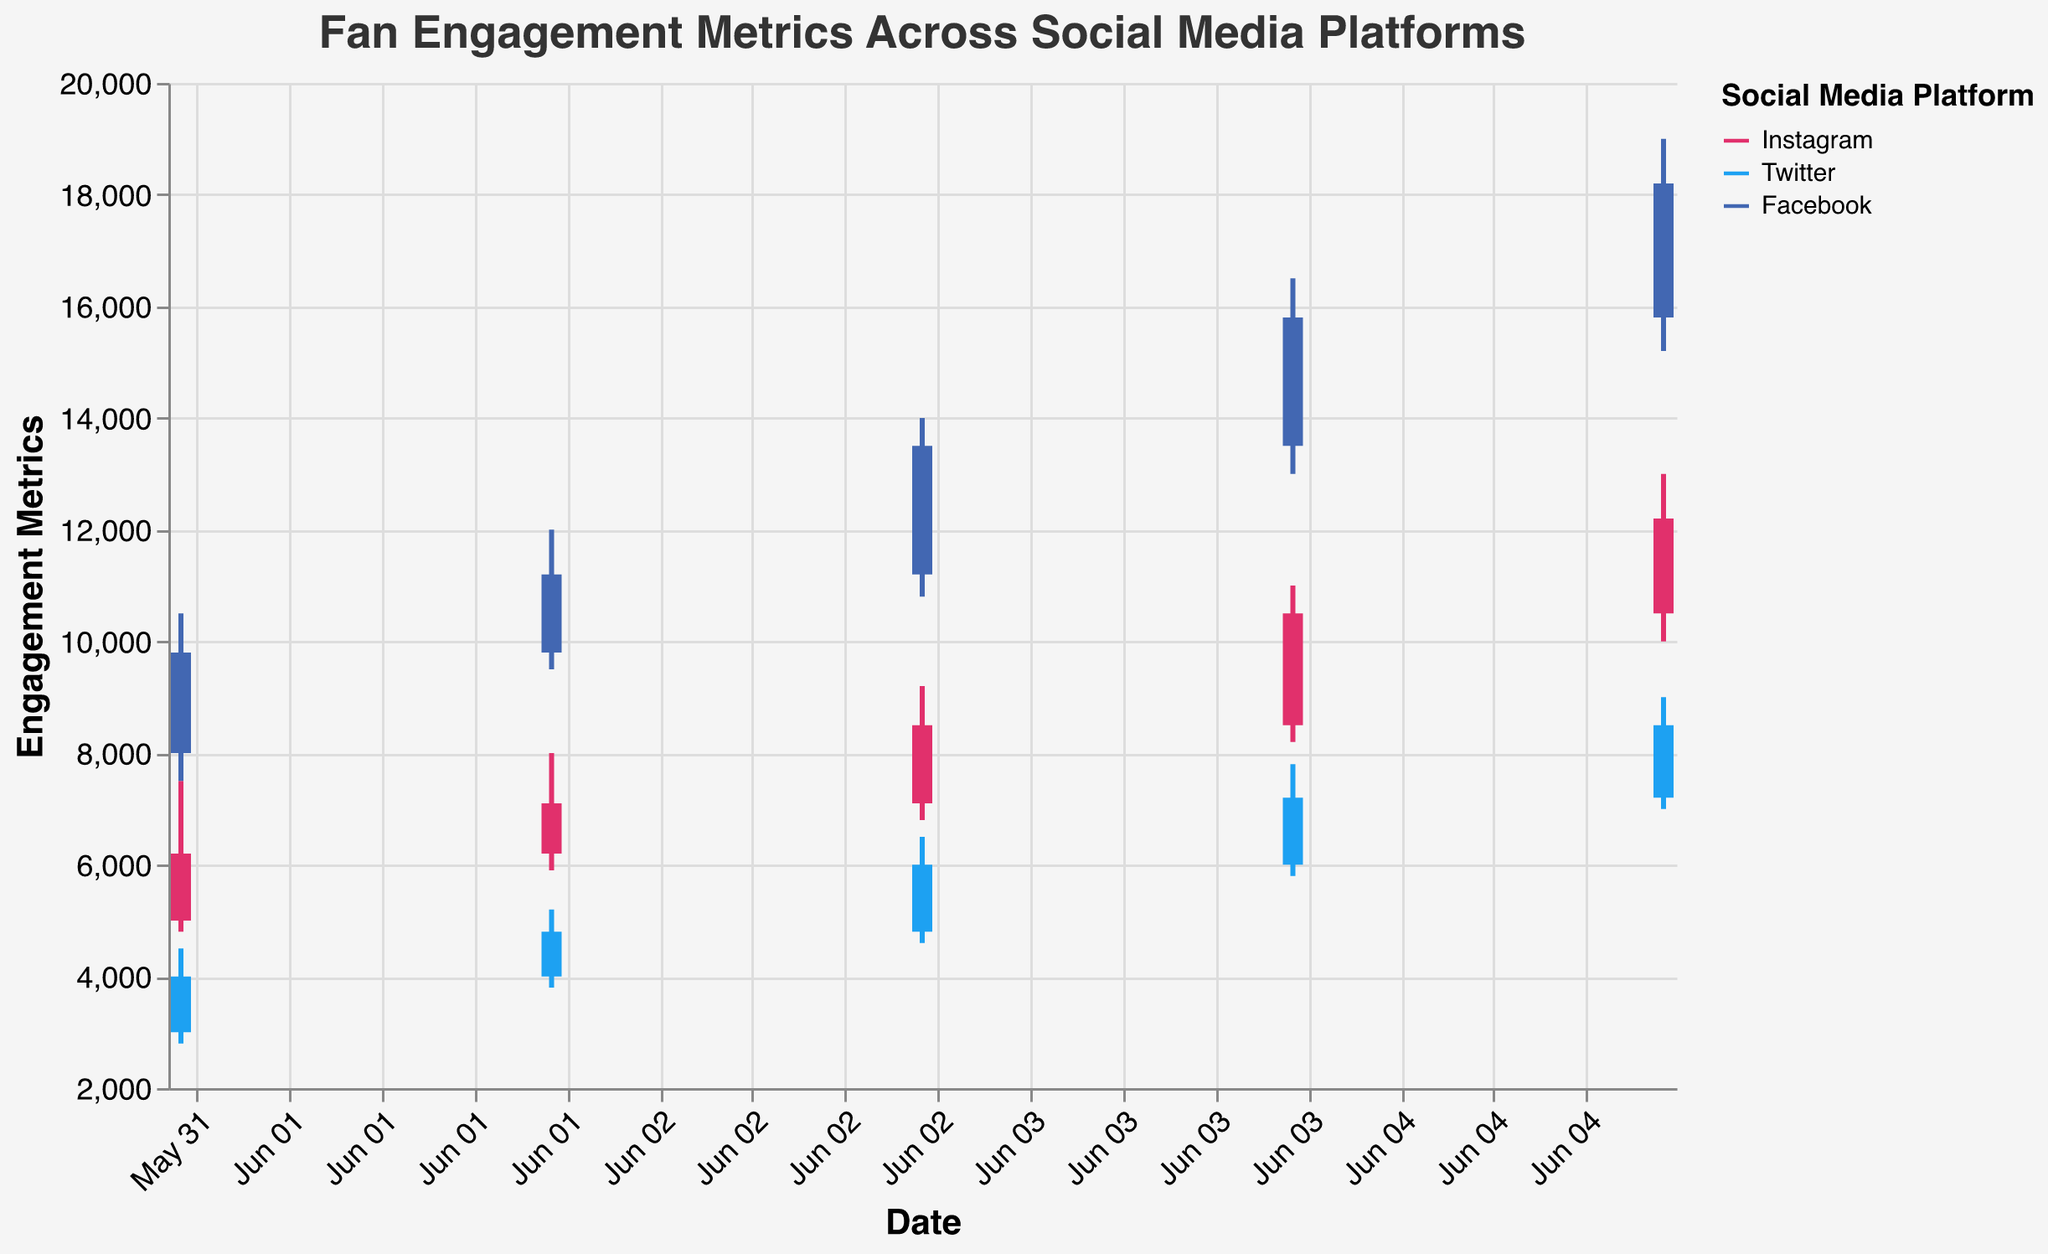What is the title of the chart? The title of the chart is located at the top and reads: "Fan Engagement Metrics Across Social Media Platforms"
Answer: Fan Engagement Metrics Across Social Media Platforms How many platforms are being compared in the chart? The chart utilizes different colors for each platform shown in the legend: Instagram (pink), Twitter (blue), and Facebook (dark blue), making a total of 3 platforms.
Answer: 3 On which date does Twitter have the highest 'High' engagement metric, and what is the value? For Twitter, the highest 'High' value is plotted at the topmost point of the day's candle. It is on the Date 2023-06-05, with a value of 9000.
Answer: June 5, 9000 What is the overall trend in engagement metrics for Facebook from June 1 to June 5? The trend can be observed by comparing the 'Close' values of each day. The 'Close' value for Facebook increases from 9800 on June 1 to 18200 on June 5, indicating an overall increasing trend.
Answer: Increasing Which platform shows the least volatile engagement metrics on June 3? Volatility can be inferred from the range between 'Low' and 'High'. On June 3, Instagram shows a range of 9200 - 6800 = 2400; Twitter shows 6500 - 4600 = 1900; and Facebook shows 14000 - 10800 = 3200. Twitter has the least range, thus least volatile.
Answer: Twitter What is the difference between the 'Open' and 'Close' engagement metrics for Instagram on June 4? On June 4, the 'Open' value for Instagram is 8500 and the 'Close' value is 10500. The difference is 10500 - 8500.
Answer: 2000 Which platform had the highest engagement 'Close' value overall, and what was the value? By looking at the 'Close' values from all three platforms and days, the highest 'Close' value is 18200 which is for Facebook on June 5.
Answer: Facebook, 18200 Compare the 'Close' values on June 2 for Instagram and Twitter. Which has a higher value? The 'Close' value for Instagram on June 2 is 7100, and for Twitter it is 4800. Therefore, Instagram has the higher value.
Answer: Instagram How much did Facebook's 'Close' engagement metric increase between June 1 and June 5? The 'Close' value on June 1 for Facebook is 9800 and on June 5 it is 18200. To find the increase, calculate 18200 - 9800.
Answer: 8400 Which date saw the smallest difference between 'High' and 'Low' engagement metrics for Instagram? By comparing the ranges ('High' - 'Low') for Instagram: June 1 (7500-4800=2700), June 2 (8000-5900=2100), June 3 (9200-6800=2400), June 4 (11000-8200=2800), June 5 (13000-10000=3000). The smallest difference is 2100 on June 2.
Answer: June 2 